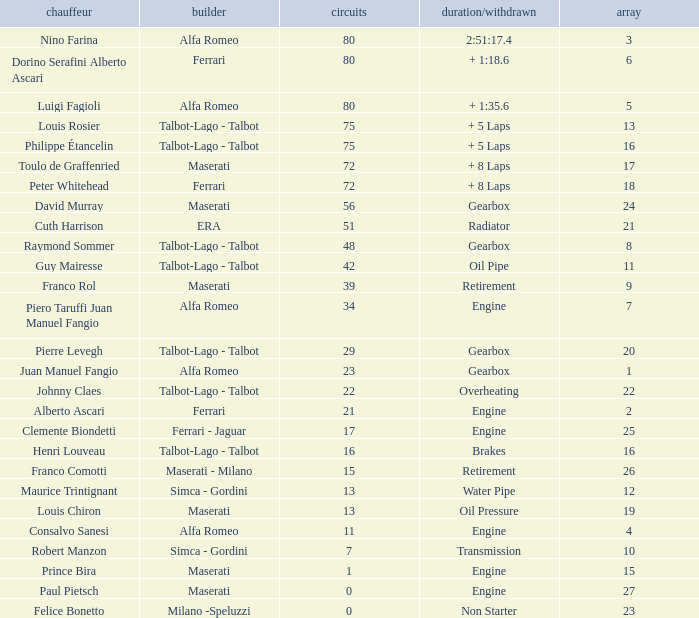When grid is less than 7, laps are greater than 17, and time/retired is + 1:35.6, who is the constructor? Alfa Romeo. 